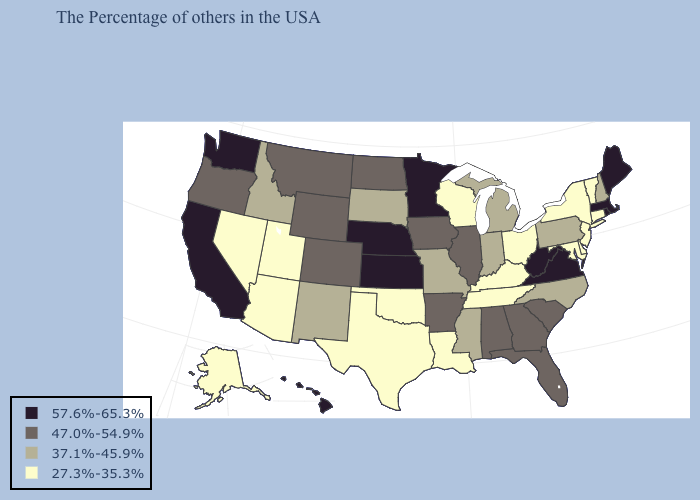Name the states that have a value in the range 37.1%-45.9%?
Write a very short answer. New Hampshire, Pennsylvania, North Carolina, Michigan, Indiana, Mississippi, Missouri, South Dakota, New Mexico, Idaho. What is the value of Oregon?
Answer briefly. 47.0%-54.9%. Among the states that border Maryland , does Pennsylvania have the lowest value?
Short answer required. No. Name the states that have a value in the range 27.3%-35.3%?
Be succinct. Vermont, Connecticut, New York, New Jersey, Delaware, Maryland, Ohio, Kentucky, Tennessee, Wisconsin, Louisiana, Oklahoma, Texas, Utah, Arizona, Nevada, Alaska. Name the states that have a value in the range 27.3%-35.3%?
Concise answer only. Vermont, Connecticut, New York, New Jersey, Delaware, Maryland, Ohio, Kentucky, Tennessee, Wisconsin, Louisiana, Oklahoma, Texas, Utah, Arizona, Nevada, Alaska. What is the lowest value in the USA?
Give a very brief answer. 27.3%-35.3%. Name the states that have a value in the range 27.3%-35.3%?
Quick response, please. Vermont, Connecticut, New York, New Jersey, Delaware, Maryland, Ohio, Kentucky, Tennessee, Wisconsin, Louisiana, Oklahoma, Texas, Utah, Arizona, Nevada, Alaska. Among the states that border Massachusetts , which have the highest value?
Give a very brief answer. Rhode Island. Is the legend a continuous bar?
Concise answer only. No. What is the value of South Dakota?
Keep it brief. 37.1%-45.9%. Does Kansas have the highest value in the MidWest?
Write a very short answer. Yes. Does Ohio have the lowest value in the MidWest?
Short answer required. Yes. What is the value of Washington?
Keep it brief. 57.6%-65.3%. Does Tennessee have the lowest value in the USA?
Short answer required. Yes. Name the states that have a value in the range 27.3%-35.3%?
Quick response, please. Vermont, Connecticut, New York, New Jersey, Delaware, Maryland, Ohio, Kentucky, Tennessee, Wisconsin, Louisiana, Oklahoma, Texas, Utah, Arizona, Nevada, Alaska. 